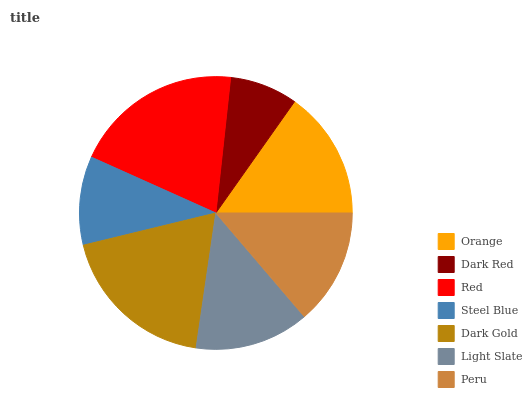Is Dark Red the minimum?
Answer yes or no. Yes. Is Red the maximum?
Answer yes or no. Yes. Is Red the minimum?
Answer yes or no. No. Is Dark Red the maximum?
Answer yes or no. No. Is Red greater than Dark Red?
Answer yes or no. Yes. Is Dark Red less than Red?
Answer yes or no. Yes. Is Dark Red greater than Red?
Answer yes or no. No. Is Red less than Dark Red?
Answer yes or no. No. Is Peru the high median?
Answer yes or no. Yes. Is Peru the low median?
Answer yes or no. Yes. Is Light Slate the high median?
Answer yes or no. No. Is Light Slate the low median?
Answer yes or no. No. 